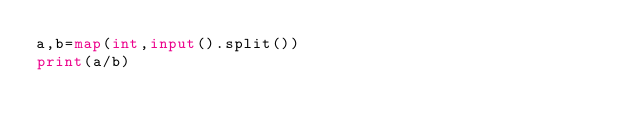Convert code to text. <code><loc_0><loc_0><loc_500><loc_500><_Python_>a,b=map(int,input().split())
print(a/b)</code> 